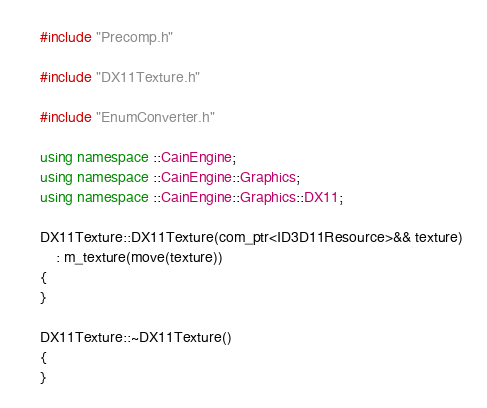<code> <loc_0><loc_0><loc_500><loc_500><_C++_>#include "Precomp.h"

#include "DX11Texture.h"

#include "EnumConverter.h"

using namespace ::CainEngine;
using namespace ::CainEngine::Graphics;
using namespace ::CainEngine::Graphics::DX11;

DX11Texture::DX11Texture(com_ptr<ID3D11Resource>&& texture)
	: m_texture(move(texture))
{
}

DX11Texture::~DX11Texture()
{
}

</code> 